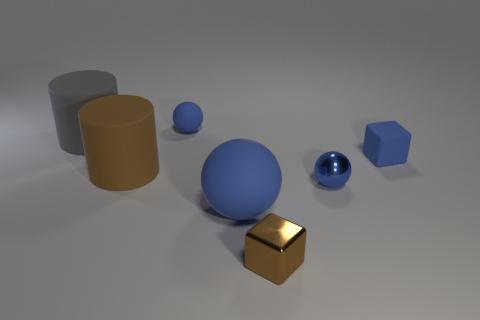Do the brown metallic cube left of the rubber cube and the large gray matte object have the same size?
Keep it short and to the point. No. There is a thing that is both in front of the small metal ball and on the right side of the big sphere; what shape is it?
Provide a succinct answer. Cube. Do the large rubber ball and the matte cylinder on the right side of the gray cylinder have the same color?
Offer a very short reply. No. What is the color of the rubber ball that is to the right of the blue rubber object that is behind the big object that is behind the rubber block?
Keep it short and to the point. Blue. The large object that is the same shape as the tiny blue metallic object is what color?
Ensure brevity in your answer.  Blue. Are there an equal number of big brown cylinders in front of the big blue ball and big green shiny spheres?
Provide a short and direct response. Yes. How many cubes are big gray rubber things or big brown objects?
Give a very brief answer. 0. There is a small block that is made of the same material as the large gray cylinder; what is its color?
Your response must be concise. Blue. Do the small brown object and the small sphere in front of the brown rubber cylinder have the same material?
Provide a succinct answer. Yes. What number of objects are either blue matte things or tiny purple matte things?
Your answer should be very brief. 3. 